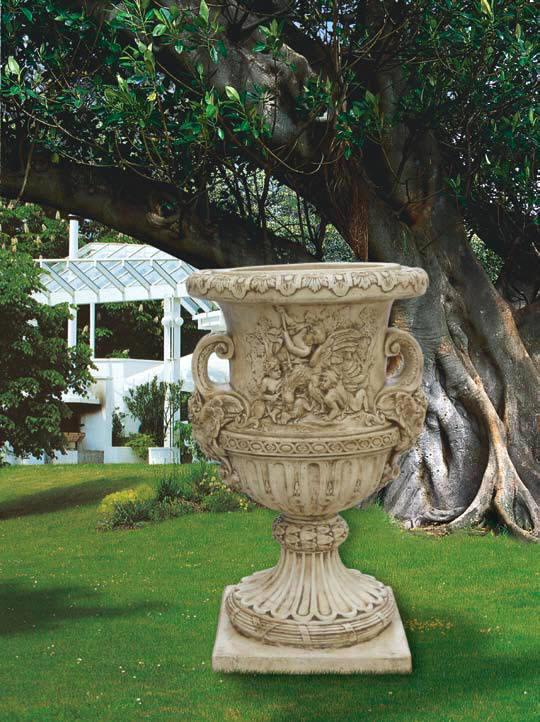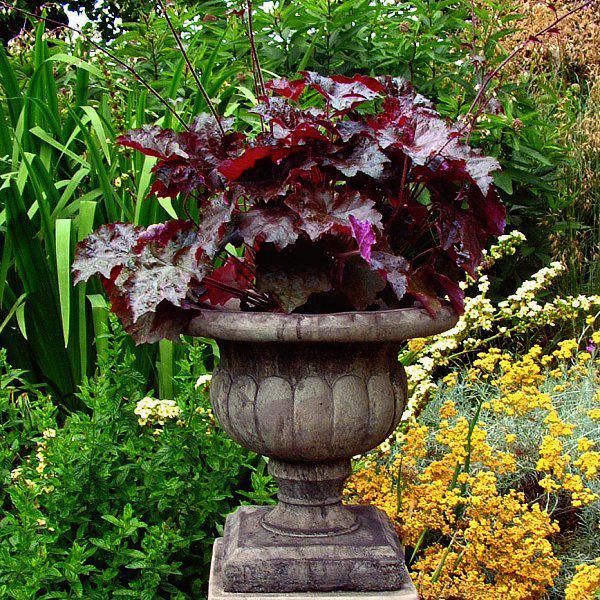The first image is the image on the left, the second image is the image on the right. Given the left and right images, does the statement "One image includes a shiny greenish vessel used as an outdoor fountain, and the other image shows a flower-filled stone-look planter with a pedestal base." hold true? Answer yes or no. No. The first image is the image on the left, the second image is the image on the right. For the images shown, is this caption "There is a vase that holds a water  fountain ." true? Answer yes or no. No. 